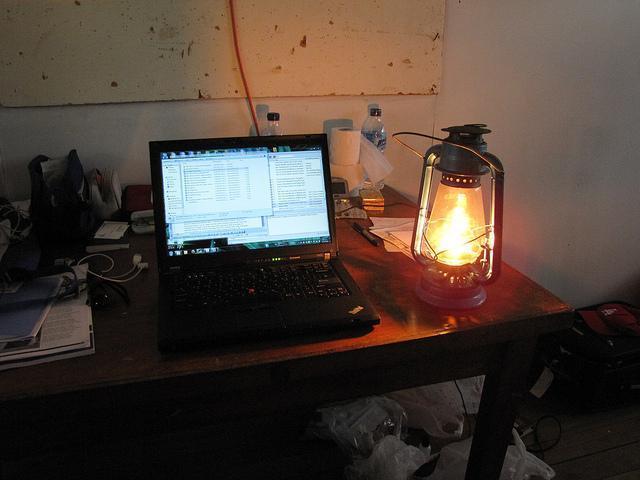How many books are in the photo?
Give a very brief answer. 1. 